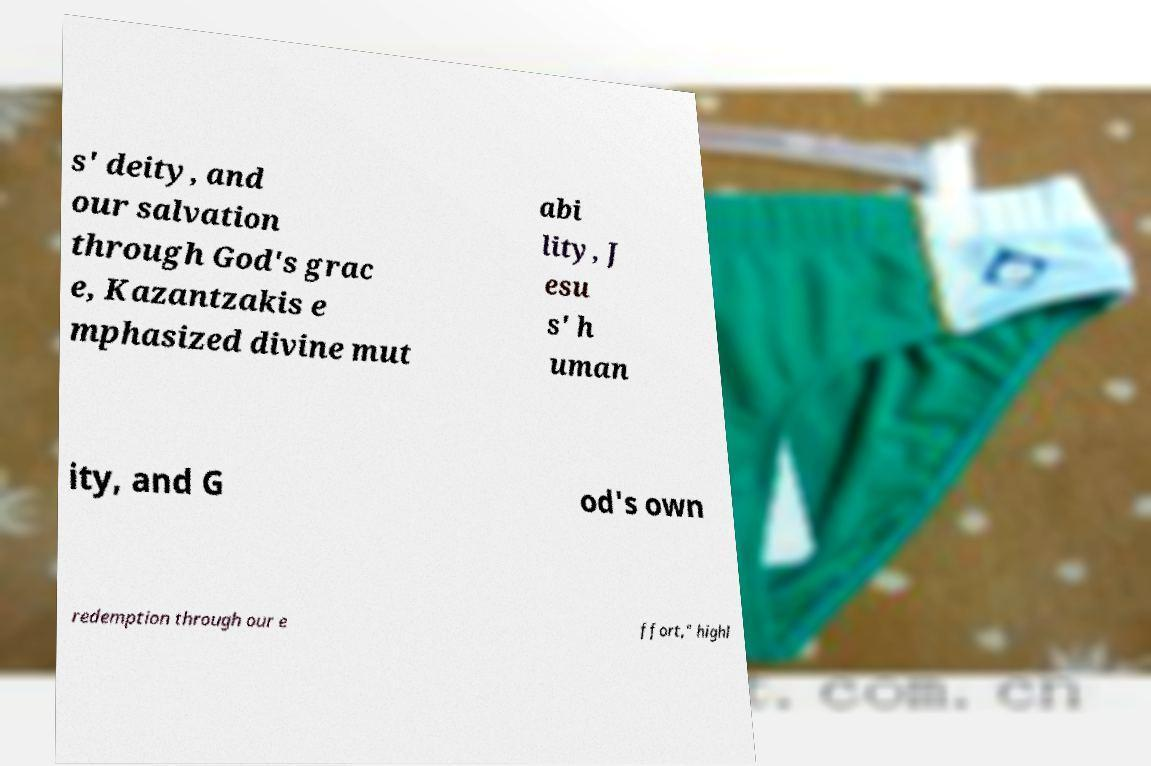Could you extract and type out the text from this image? s' deity, and our salvation through God's grac e, Kazantzakis e mphasized divine mut abi lity, J esu s' h uman ity, and G od's own redemption through our e ffort," highl 